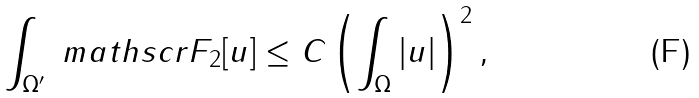Convert formula to latex. <formula><loc_0><loc_0><loc_500><loc_500>\int _ { \Omega ^ { \prime } } \ m a t h s c r { F } _ { 2 } [ u ] \leq C \left ( \int _ { \Omega } \left | u \right | \right ) ^ { 2 } ,</formula> 